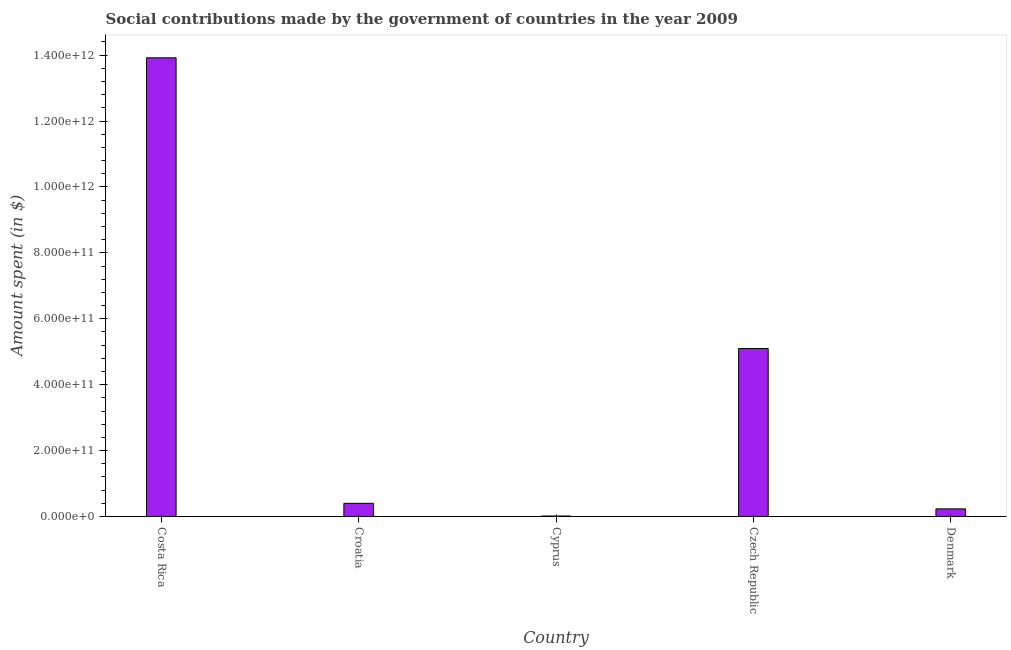What is the title of the graph?
Offer a terse response. Social contributions made by the government of countries in the year 2009. What is the label or title of the X-axis?
Keep it short and to the point. Country. What is the label or title of the Y-axis?
Ensure brevity in your answer.  Amount spent (in $). What is the amount spent in making social contributions in Croatia?
Keep it short and to the point. 4.00e+1. Across all countries, what is the maximum amount spent in making social contributions?
Your answer should be very brief. 1.39e+12. Across all countries, what is the minimum amount spent in making social contributions?
Provide a succinct answer. 1.46e+09. In which country was the amount spent in making social contributions maximum?
Offer a very short reply. Costa Rica. In which country was the amount spent in making social contributions minimum?
Offer a very short reply. Cyprus. What is the sum of the amount spent in making social contributions?
Ensure brevity in your answer.  1.97e+12. What is the difference between the amount spent in making social contributions in Costa Rica and Denmark?
Offer a terse response. 1.37e+12. What is the average amount spent in making social contributions per country?
Offer a terse response. 3.93e+11. What is the median amount spent in making social contributions?
Your response must be concise. 4.00e+1. In how many countries, is the amount spent in making social contributions greater than 1400000000000 $?
Give a very brief answer. 0. What is the ratio of the amount spent in making social contributions in Cyprus to that in Denmark?
Offer a very short reply. 0.06. Is the difference between the amount spent in making social contributions in Cyprus and Czech Republic greater than the difference between any two countries?
Your response must be concise. No. What is the difference between the highest and the second highest amount spent in making social contributions?
Your answer should be very brief. 8.82e+11. What is the difference between the highest and the lowest amount spent in making social contributions?
Offer a terse response. 1.39e+12. In how many countries, is the amount spent in making social contributions greater than the average amount spent in making social contributions taken over all countries?
Your answer should be very brief. 2. How many bars are there?
Provide a succinct answer. 5. Are all the bars in the graph horizontal?
Your response must be concise. No. How many countries are there in the graph?
Provide a succinct answer. 5. What is the difference between two consecutive major ticks on the Y-axis?
Provide a succinct answer. 2.00e+11. What is the Amount spent (in $) in Costa Rica?
Provide a succinct answer. 1.39e+12. What is the Amount spent (in $) in Croatia?
Provide a short and direct response. 4.00e+1. What is the Amount spent (in $) in Cyprus?
Keep it short and to the point. 1.46e+09. What is the Amount spent (in $) of Czech Republic?
Your answer should be very brief. 5.10e+11. What is the Amount spent (in $) in Denmark?
Your answer should be very brief. 2.31e+1. What is the difference between the Amount spent (in $) in Costa Rica and Croatia?
Your answer should be very brief. 1.35e+12. What is the difference between the Amount spent (in $) in Costa Rica and Cyprus?
Ensure brevity in your answer.  1.39e+12. What is the difference between the Amount spent (in $) in Costa Rica and Czech Republic?
Your answer should be compact. 8.82e+11. What is the difference between the Amount spent (in $) in Costa Rica and Denmark?
Your response must be concise. 1.37e+12. What is the difference between the Amount spent (in $) in Croatia and Cyprus?
Provide a succinct answer. 3.85e+1. What is the difference between the Amount spent (in $) in Croatia and Czech Republic?
Your answer should be very brief. -4.70e+11. What is the difference between the Amount spent (in $) in Croatia and Denmark?
Offer a terse response. 1.69e+1. What is the difference between the Amount spent (in $) in Cyprus and Czech Republic?
Provide a short and direct response. -5.08e+11. What is the difference between the Amount spent (in $) in Cyprus and Denmark?
Offer a very short reply. -2.16e+1. What is the difference between the Amount spent (in $) in Czech Republic and Denmark?
Your response must be concise. 4.87e+11. What is the ratio of the Amount spent (in $) in Costa Rica to that in Croatia?
Offer a very short reply. 34.8. What is the ratio of the Amount spent (in $) in Costa Rica to that in Cyprus?
Provide a succinct answer. 950.61. What is the ratio of the Amount spent (in $) in Costa Rica to that in Czech Republic?
Ensure brevity in your answer.  2.73. What is the ratio of the Amount spent (in $) in Costa Rica to that in Denmark?
Offer a very short reply. 60.35. What is the ratio of the Amount spent (in $) in Croatia to that in Cyprus?
Make the answer very short. 27.32. What is the ratio of the Amount spent (in $) in Croatia to that in Czech Republic?
Provide a short and direct response. 0.08. What is the ratio of the Amount spent (in $) in Croatia to that in Denmark?
Keep it short and to the point. 1.73. What is the ratio of the Amount spent (in $) in Cyprus to that in Czech Republic?
Your answer should be very brief. 0. What is the ratio of the Amount spent (in $) in Cyprus to that in Denmark?
Your response must be concise. 0.06. What is the ratio of the Amount spent (in $) in Czech Republic to that in Denmark?
Your answer should be compact. 22.1. 